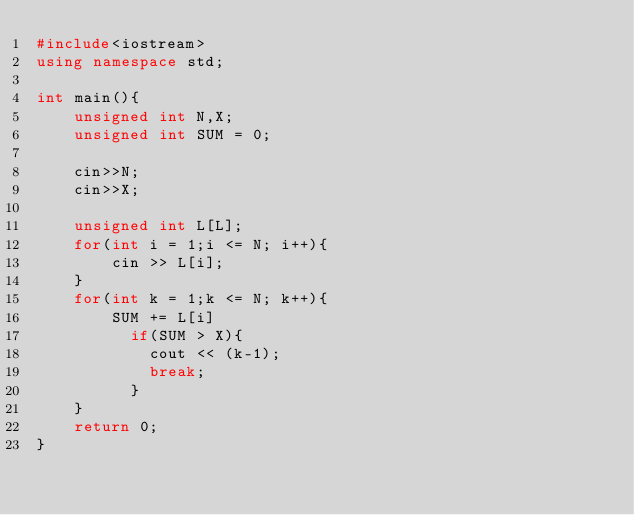<code> <loc_0><loc_0><loc_500><loc_500><_C++_>#include<iostream>
using namespace std;
 
int main(){
  	unsigned int N,X;
	unsigned int SUM = 0;
 
	cin>>N;
  	cin>>X;
  
  	unsigned int L[L];
	for(int i = 1;i <= N; i++){
    	cin >> L[i];
    }
	for(int k = 1;k <= N; k++){
      	SUM += L[i]
          if(SUM > X){
          	cout << (k-1);
            break;
          }
    }
  	return 0;
}</code> 